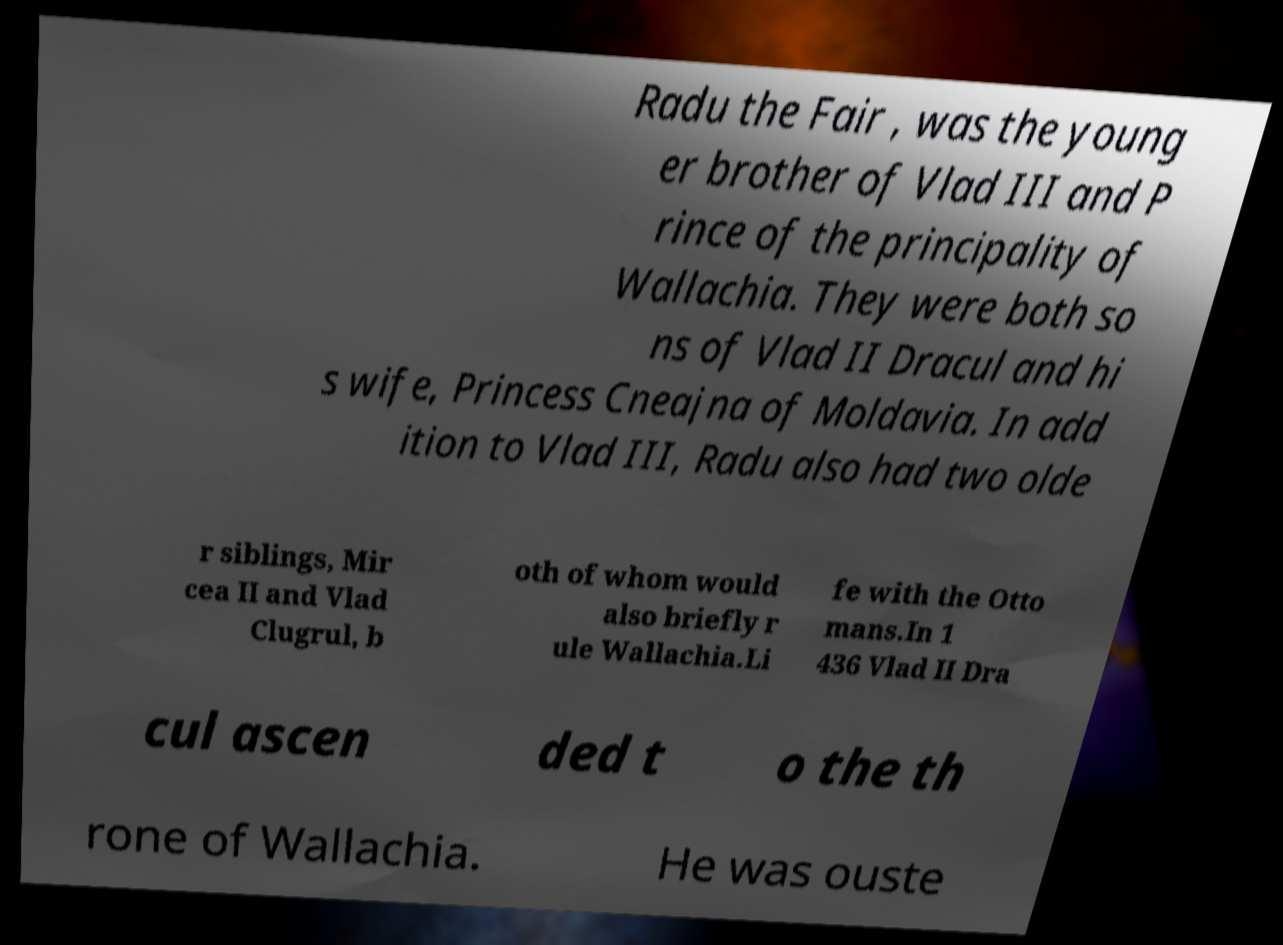For documentation purposes, I need the text within this image transcribed. Could you provide that? Radu the Fair , was the young er brother of Vlad III and P rince of the principality of Wallachia. They were both so ns of Vlad II Dracul and hi s wife, Princess Cneajna of Moldavia. In add ition to Vlad III, Radu also had two olde r siblings, Mir cea II and Vlad Clugrul, b oth of whom would also briefly r ule Wallachia.Li fe with the Otto mans.In 1 436 Vlad II Dra cul ascen ded t o the th rone of Wallachia. He was ouste 